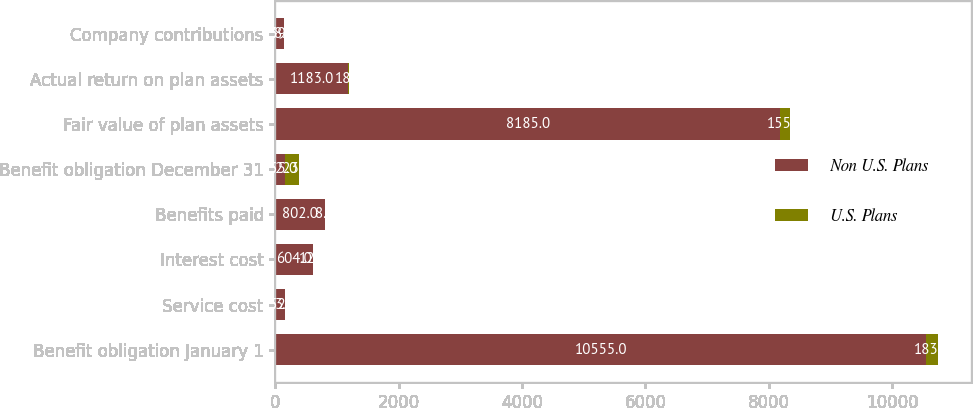Convert chart to OTSL. <chart><loc_0><loc_0><loc_500><loc_500><stacked_bar_chart><ecel><fcel>Benefit obligation January 1<fcel>Service cost<fcel>Interest cost<fcel>Benefits paid<fcel>Benefit obligation December 31<fcel>Fair value of plan assets<fcel>Actual return on plan assets<fcel>Company contributions<nl><fcel>Non U.S. Plans<fcel>10555<fcel>152<fcel>604<fcel>802<fcel>155<fcel>8185<fcel>1183<fcel>139<nl><fcel>U.S. Plans<fcel>183<fcel>3<fcel>12<fcel>8<fcel>223<fcel>155<fcel>18<fcel>8<nl></chart> 